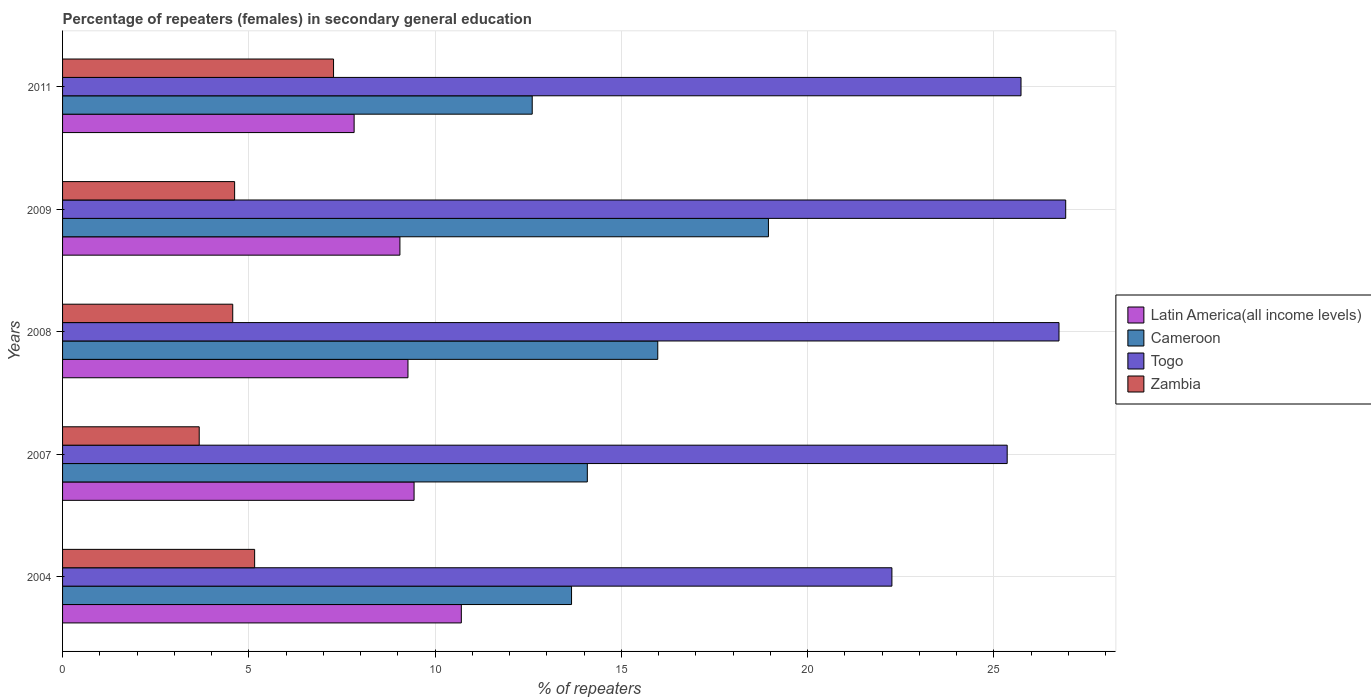How many different coloured bars are there?
Make the answer very short. 4. How many groups of bars are there?
Provide a succinct answer. 5. Are the number of bars per tick equal to the number of legend labels?
Offer a very short reply. Yes. Are the number of bars on each tick of the Y-axis equal?
Offer a terse response. Yes. How many bars are there on the 4th tick from the bottom?
Ensure brevity in your answer.  4. What is the label of the 4th group of bars from the top?
Offer a very short reply. 2007. In how many cases, is the number of bars for a given year not equal to the number of legend labels?
Ensure brevity in your answer.  0. What is the percentage of female repeaters in Latin America(all income levels) in 2008?
Your answer should be compact. 9.27. Across all years, what is the maximum percentage of female repeaters in Cameroon?
Provide a short and direct response. 18.95. Across all years, what is the minimum percentage of female repeaters in Cameroon?
Your answer should be compact. 12.61. In which year was the percentage of female repeaters in Togo minimum?
Provide a succinct answer. 2004. What is the total percentage of female repeaters in Cameroon in the graph?
Offer a terse response. 75.29. What is the difference between the percentage of female repeaters in Latin America(all income levels) in 2008 and that in 2011?
Your answer should be compact. 1.45. What is the difference between the percentage of female repeaters in Cameroon in 2008 and the percentage of female repeaters in Latin America(all income levels) in 2007?
Your answer should be compact. 6.54. What is the average percentage of female repeaters in Latin America(all income levels) per year?
Ensure brevity in your answer.  9.26. In the year 2007, what is the difference between the percentage of female repeaters in Cameroon and percentage of female repeaters in Togo?
Offer a terse response. -11.27. In how many years, is the percentage of female repeaters in Togo greater than 23 %?
Your answer should be compact. 4. What is the ratio of the percentage of female repeaters in Cameroon in 2004 to that in 2007?
Ensure brevity in your answer.  0.97. Is the difference between the percentage of female repeaters in Cameroon in 2008 and 2009 greater than the difference between the percentage of female repeaters in Togo in 2008 and 2009?
Make the answer very short. No. What is the difference between the highest and the second highest percentage of female repeaters in Togo?
Your answer should be very brief. 0.18. What is the difference between the highest and the lowest percentage of female repeaters in Zambia?
Provide a succinct answer. 3.61. In how many years, is the percentage of female repeaters in Cameroon greater than the average percentage of female repeaters in Cameroon taken over all years?
Offer a terse response. 2. Is it the case that in every year, the sum of the percentage of female repeaters in Zambia and percentage of female repeaters in Latin America(all income levels) is greater than the sum of percentage of female repeaters in Togo and percentage of female repeaters in Cameroon?
Provide a short and direct response. No. What does the 2nd bar from the top in 2007 represents?
Ensure brevity in your answer.  Togo. What does the 1st bar from the bottom in 2009 represents?
Give a very brief answer. Latin America(all income levels). Is it the case that in every year, the sum of the percentage of female repeaters in Togo and percentage of female repeaters in Cameroon is greater than the percentage of female repeaters in Latin America(all income levels)?
Your answer should be compact. Yes. Are all the bars in the graph horizontal?
Your answer should be compact. Yes. Are the values on the major ticks of X-axis written in scientific E-notation?
Your answer should be very brief. No. Where does the legend appear in the graph?
Provide a succinct answer. Center right. What is the title of the graph?
Provide a short and direct response. Percentage of repeaters (females) in secondary general education. What is the label or title of the X-axis?
Ensure brevity in your answer.  % of repeaters. What is the label or title of the Y-axis?
Your response must be concise. Years. What is the % of repeaters of Latin America(all income levels) in 2004?
Provide a short and direct response. 10.7. What is the % of repeaters in Cameroon in 2004?
Offer a terse response. 13.66. What is the % of repeaters of Togo in 2004?
Keep it short and to the point. 22.26. What is the % of repeaters of Zambia in 2004?
Make the answer very short. 5.16. What is the % of repeaters in Latin America(all income levels) in 2007?
Give a very brief answer. 9.44. What is the % of repeaters of Cameroon in 2007?
Your response must be concise. 14.09. What is the % of repeaters in Togo in 2007?
Offer a very short reply. 25.36. What is the % of repeaters in Zambia in 2007?
Your answer should be very brief. 3.67. What is the % of repeaters of Latin America(all income levels) in 2008?
Ensure brevity in your answer.  9.27. What is the % of repeaters in Cameroon in 2008?
Keep it short and to the point. 15.98. What is the % of repeaters in Togo in 2008?
Offer a terse response. 26.75. What is the % of repeaters of Zambia in 2008?
Your response must be concise. 4.57. What is the % of repeaters of Latin America(all income levels) in 2009?
Offer a terse response. 9.06. What is the % of repeaters of Cameroon in 2009?
Offer a very short reply. 18.95. What is the % of repeaters in Togo in 2009?
Offer a very short reply. 26.93. What is the % of repeaters of Zambia in 2009?
Your answer should be very brief. 4.62. What is the % of repeaters in Latin America(all income levels) in 2011?
Your answer should be compact. 7.83. What is the % of repeaters in Cameroon in 2011?
Give a very brief answer. 12.61. What is the % of repeaters in Togo in 2011?
Provide a short and direct response. 25.73. What is the % of repeaters in Zambia in 2011?
Offer a very short reply. 7.27. Across all years, what is the maximum % of repeaters of Latin America(all income levels)?
Provide a short and direct response. 10.7. Across all years, what is the maximum % of repeaters in Cameroon?
Keep it short and to the point. 18.95. Across all years, what is the maximum % of repeaters of Togo?
Provide a succinct answer. 26.93. Across all years, what is the maximum % of repeaters of Zambia?
Give a very brief answer. 7.27. Across all years, what is the minimum % of repeaters of Latin America(all income levels)?
Provide a succinct answer. 7.83. Across all years, what is the minimum % of repeaters of Cameroon?
Your response must be concise. 12.61. Across all years, what is the minimum % of repeaters in Togo?
Provide a short and direct response. 22.26. Across all years, what is the minimum % of repeaters of Zambia?
Give a very brief answer. 3.67. What is the total % of repeaters of Latin America(all income levels) in the graph?
Your answer should be compact. 46.3. What is the total % of repeaters of Cameroon in the graph?
Give a very brief answer. 75.29. What is the total % of repeaters of Togo in the graph?
Your answer should be very brief. 127.03. What is the total % of repeaters of Zambia in the graph?
Give a very brief answer. 25.29. What is the difference between the % of repeaters of Latin America(all income levels) in 2004 and that in 2007?
Your response must be concise. 1.27. What is the difference between the % of repeaters of Cameroon in 2004 and that in 2007?
Ensure brevity in your answer.  -0.42. What is the difference between the % of repeaters in Togo in 2004 and that in 2007?
Keep it short and to the point. -3.09. What is the difference between the % of repeaters of Zambia in 2004 and that in 2007?
Make the answer very short. 1.49. What is the difference between the % of repeaters of Latin America(all income levels) in 2004 and that in 2008?
Offer a very short reply. 1.43. What is the difference between the % of repeaters in Cameroon in 2004 and that in 2008?
Your answer should be very brief. -2.31. What is the difference between the % of repeaters of Togo in 2004 and that in 2008?
Offer a terse response. -4.49. What is the difference between the % of repeaters in Zambia in 2004 and that in 2008?
Your answer should be very brief. 0.59. What is the difference between the % of repeaters in Latin America(all income levels) in 2004 and that in 2009?
Make the answer very short. 1.65. What is the difference between the % of repeaters of Cameroon in 2004 and that in 2009?
Offer a terse response. -5.29. What is the difference between the % of repeaters of Togo in 2004 and that in 2009?
Ensure brevity in your answer.  -4.67. What is the difference between the % of repeaters in Zambia in 2004 and that in 2009?
Ensure brevity in your answer.  0.54. What is the difference between the % of repeaters in Latin America(all income levels) in 2004 and that in 2011?
Ensure brevity in your answer.  2.88. What is the difference between the % of repeaters in Cameroon in 2004 and that in 2011?
Your response must be concise. 1.06. What is the difference between the % of repeaters of Togo in 2004 and that in 2011?
Keep it short and to the point. -3.47. What is the difference between the % of repeaters in Zambia in 2004 and that in 2011?
Offer a very short reply. -2.12. What is the difference between the % of repeaters in Latin America(all income levels) in 2007 and that in 2008?
Ensure brevity in your answer.  0.16. What is the difference between the % of repeaters of Cameroon in 2007 and that in 2008?
Your response must be concise. -1.89. What is the difference between the % of repeaters of Togo in 2007 and that in 2008?
Ensure brevity in your answer.  -1.39. What is the difference between the % of repeaters in Latin America(all income levels) in 2007 and that in 2009?
Keep it short and to the point. 0.38. What is the difference between the % of repeaters in Cameroon in 2007 and that in 2009?
Provide a short and direct response. -4.86. What is the difference between the % of repeaters of Togo in 2007 and that in 2009?
Keep it short and to the point. -1.57. What is the difference between the % of repeaters in Zambia in 2007 and that in 2009?
Offer a very short reply. -0.95. What is the difference between the % of repeaters in Latin America(all income levels) in 2007 and that in 2011?
Offer a terse response. 1.61. What is the difference between the % of repeaters of Cameroon in 2007 and that in 2011?
Keep it short and to the point. 1.48. What is the difference between the % of repeaters in Togo in 2007 and that in 2011?
Give a very brief answer. -0.37. What is the difference between the % of repeaters of Zambia in 2007 and that in 2011?
Give a very brief answer. -3.61. What is the difference between the % of repeaters in Latin America(all income levels) in 2008 and that in 2009?
Your answer should be very brief. 0.22. What is the difference between the % of repeaters in Cameroon in 2008 and that in 2009?
Your response must be concise. -2.97. What is the difference between the % of repeaters in Togo in 2008 and that in 2009?
Ensure brevity in your answer.  -0.18. What is the difference between the % of repeaters in Zambia in 2008 and that in 2009?
Your answer should be compact. -0.05. What is the difference between the % of repeaters in Latin America(all income levels) in 2008 and that in 2011?
Offer a very short reply. 1.45. What is the difference between the % of repeaters of Cameroon in 2008 and that in 2011?
Provide a succinct answer. 3.37. What is the difference between the % of repeaters in Togo in 2008 and that in 2011?
Offer a terse response. 1.02. What is the difference between the % of repeaters of Zambia in 2008 and that in 2011?
Offer a terse response. -2.71. What is the difference between the % of repeaters in Latin America(all income levels) in 2009 and that in 2011?
Keep it short and to the point. 1.23. What is the difference between the % of repeaters in Cameroon in 2009 and that in 2011?
Ensure brevity in your answer.  6.34. What is the difference between the % of repeaters in Zambia in 2009 and that in 2011?
Provide a succinct answer. -2.66. What is the difference between the % of repeaters in Latin America(all income levels) in 2004 and the % of repeaters in Cameroon in 2007?
Give a very brief answer. -3.38. What is the difference between the % of repeaters in Latin America(all income levels) in 2004 and the % of repeaters in Togo in 2007?
Your answer should be compact. -14.65. What is the difference between the % of repeaters of Latin America(all income levels) in 2004 and the % of repeaters of Zambia in 2007?
Your response must be concise. 7.04. What is the difference between the % of repeaters of Cameroon in 2004 and the % of repeaters of Togo in 2007?
Your answer should be very brief. -11.7. What is the difference between the % of repeaters of Cameroon in 2004 and the % of repeaters of Zambia in 2007?
Your answer should be compact. 10. What is the difference between the % of repeaters in Togo in 2004 and the % of repeaters in Zambia in 2007?
Offer a very short reply. 18.6. What is the difference between the % of repeaters in Latin America(all income levels) in 2004 and the % of repeaters in Cameroon in 2008?
Your answer should be compact. -5.27. What is the difference between the % of repeaters in Latin America(all income levels) in 2004 and the % of repeaters in Togo in 2008?
Offer a very short reply. -16.04. What is the difference between the % of repeaters in Latin America(all income levels) in 2004 and the % of repeaters in Zambia in 2008?
Offer a very short reply. 6.14. What is the difference between the % of repeaters of Cameroon in 2004 and the % of repeaters of Togo in 2008?
Offer a terse response. -13.09. What is the difference between the % of repeaters of Cameroon in 2004 and the % of repeaters of Zambia in 2008?
Provide a succinct answer. 9.1. What is the difference between the % of repeaters in Togo in 2004 and the % of repeaters in Zambia in 2008?
Keep it short and to the point. 17.7. What is the difference between the % of repeaters in Latin America(all income levels) in 2004 and the % of repeaters in Cameroon in 2009?
Offer a very short reply. -8.24. What is the difference between the % of repeaters in Latin America(all income levels) in 2004 and the % of repeaters in Togo in 2009?
Provide a short and direct response. -16.22. What is the difference between the % of repeaters in Latin America(all income levels) in 2004 and the % of repeaters in Zambia in 2009?
Provide a succinct answer. 6.09. What is the difference between the % of repeaters of Cameroon in 2004 and the % of repeaters of Togo in 2009?
Offer a terse response. -13.27. What is the difference between the % of repeaters in Cameroon in 2004 and the % of repeaters in Zambia in 2009?
Provide a succinct answer. 9.04. What is the difference between the % of repeaters in Togo in 2004 and the % of repeaters in Zambia in 2009?
Provide a short and direct response. 17.65. What is the difference between the % of repeaters of Latin America(all income levels) in 2004 and the % of repeaters of Cameroon in 2011?
Your answer should be very brief. -1.9. What is the difference between the % of repeaters of Latin America(all income levels) in 2004 and the % of repeaters of Togo in 2011?
Your answer should be very brief. -15.02. What is the difference between the % of repeaters in Latin America(all income levels) in 2004 and the % of repeaters in Zambia in 2011?
Provide a succinct answer. 3.43. What is the difference between the % of repeaters of Cameroon in 2004 and the % of repeaters of Togo in 2011?
Provide a short and direct response. -12.07. What is the difference between the % of repeaters in Cameroon in 2004 and the % of repeaters in Zambia in 2011?
Keep it short and to the point. 6.39. What is the difference between the % of repeaters of Togo in 2004 and the % of repeaters of Zambia in 2011?
Offer a very short reply. 14.99. What is the difference between the % of repeaters of Latin America(all income levels) in 2007 and the % of repeaters of Cameroon in 2008?
Provide a succinct answer. -6.54. What is the difference between the % of repeaters in Latin America(all income levels) in 2007 and the % of repeaters in Togo in 2008?
Make the answer very short. -17.31. What is the difference between the % of repeaters in Latin America(all income levels) in 2007 and the % of repeaters in Zambia in 2008?
Your response must be concise. 4.87. What is the difference between the % of repeaters in Cameroon in 2007 and the % of repeaters in Togo in 2008?
Offer a very short reply. -12.66. What is the difference between the % of repeaters of Cameroon in 2007 and the % of repeaters of Zambia in 2008?
Offer a very short reply. 9.52. What is the difference between the % of repeaters of Togo in 2007 and the % of repeaters of Zambia in 2008?
Your answer should be compact. 20.79. What is the difference between the % of repeaters of Latin America(all income levels) in 2007 and the % of repeaters of Cameroon in 2009?
Your response must be concise. -9.51. What is the difference between the % of repeaters in Latin America(all income levels) in 2007 and the % of repeaters in Togo in 2009?
Your answer should be very brief. -17.49. What is the difference between the % of repeaters in Latin America(all income levels) in 2007 and the % of repeaters in Zambia in 2009?
Ensure brevity in your answer.  4.82. What is the difference between the % of repeaters of Cameroon in 2007 and the % of repeaters of Togo in 2009?
Provide a succinct answer. -12.84. What is the difference between the % of repeaters of Cameroon in 2007 and the % of repeaters of Zambia in 2009?
Offer a terse response. 9.47. What is the difference between the % of repeaters of Togo in 2007 and the % of repeaters of Zambia in 2009?
Offer a very short reply. 20.74. What is the difference between the % of repeaters in Latin America(all income levels) in 2007 and the % of repeaters in Cameroon in 2011?
Your answer should be very brief. -3.17. What is the difference between the % of repeaters of Latin America(all income levels) in 2007 and the % of repeaters of Togo in 2011?
Keep it short and to the point. -16.29. What is the difference between the % of repeaters of Latin America(all income levels) in 2007 and the % of repeaters of Zambia in 2011?
Make the answer very short. 2.16. What is the difference between the % of repeaters of Cameroon in 2007 and the % of repeaters of Togo in 2011?
Offer a very short reply. -11.64. What is the difference between the % of repeaters in Cameroon in 2007 and the % of repeaters in Zambia in 2011?
Keep it short and to the point. 6.81. What is the difference between the % of repeaters in Togo in 2007 and the % of repeaters in Zambia in 2011?
Provide a succinct answer. 18.08. What is the difference between the % of repeaters in Latin America(all income levels) in 2008 and the % of repeaters in Cameroon in 2009?
Keep it short and to the point. -9.68. What is the difference between the % of repeaters in Latin America(all income levels) in 2008 and the % of repeaters in Togo in 2009?
Provide a short and direct response. -17.66. What is the difference between the % of repeaters in Latin America(all income levels) in 2008 and the % of repeaters in Zambia in 2009?
Make the answer very short. 4.65. What is the difference between the % of repeaters of Cameroon in 2008 and the % of repeaters of Togo in 2009?
Ensure brevity in your answer.  -10.95. What is the difference between the % of repeaters in Cameroon in 2008 and the % of repeaters in Zambia in 2009?
Provide a succinct answer. 11.36. What is the difference between the % of repeaters in Togo in 2008 and the % of repeaters in Zambia in 2009?
Provide a short and direct response. 22.13. What is the difference between the % of repeaters in Latin America(all income levels) in 2008 and the % of repeaters in Cameroon in 2011?
Provide a succinct answer. -3.34. What is the difference between the % of repeaters in Latin America(all income levels) in 2008 and the % of repeaters in Togo in 2011?
Make the answer very short. -16.46. What is the difference between the % of repeaters of Latin America(all income levels) in 2008 and the % of repeaters of Zambia in 2011?
Make the answer very short. 2. What is the difference between the % of repeaters in Cameroon in 2008 and the % of repeaters in Togo in 2011?
Your response must be concise. -9.75. What is the difference between the % of repeaters in Cameroon in 2008 and the % of repeaters in Zambia in 2011?
Give a very brief answer. 8.7. What is the difference between the % of repeaters of Togo in 2008 and the % of repeaters of Zambia in 2011?
Offer a terse response. 19.47. What is the difference between the % of repeaters of Latin America(all income levels) in 2009 and the % of repeaters of Cameroon in 2011?
Offer a terse response. -3.55. What is the difference between the % of repeaters of Latin America(all income levels) in 2009 and the % of repeaters of Togo in 2011?
Your answer should be compact. -16.67. What is the difference between the % of repeaters of Latin America(all income levels) in 2009 and the % of repeaters of Zambia in 2011?
Offer a very short reply. 1.78. What is the difference between the % of repeaters of Cameroon in 2009 and the % of repeaters of Togo in 2011?
Make the answer very short. -6.78. What is the difference between the % of repeaters of Cameroon in 2009 and the % of repeaters of Zambia in 2011?
Your response must be concise. 11.67. What is the difference between the % of repeaters in Togo in 2009 and the % of repeaters in Zambia in 2011?
Your answer should be very brief. 19.66. What is the average % of repeaters of Latin America(all income levels) per year?
Your answer should be very brief. 9.26. What is the average % of repeaters of Cameroon per year?
Provide a succinct answer. 15.06. What is the average % of repeaters of Togo per year?
Keep it short and to the point. 25.41. What is the average % of repeaters of Zambia per year?
Keep it short and to the point. 5.06. In the year 2004, what is the difference between the % of repeaters of Latin America(all income levels) and % of repeaters of Cameroon?
Give a very brief answer. -2.96. In the year 2004, what is the difference between the % of repeaters of Latin America(all income levels) and % of repeaters of Togo?
Make the answer very short. -11.56. In the year 2004, what is the difference between the % of repeaters in Latin America(all income levels) and % of repeaters in Zambia?
Offer a very short reply. 5.55. In the year 2004, what is the difference between the % of repeaters of Cameroon and % of repeaters of Togo?
Provide a short and direct response. -8.6. In the year 2004, what is the difference between the % of repeaters in Cameroon and % of repeaters in Zambia?
Ensure brevity in your answer.  8.51. In the year 2004, what is the difference between the % of repeaters of Togo and % of repeaters of Zambia?
Provide a short and direct response. 17.11. In the year 2007, what is the difference between the % of repeaters in Latin America(all income levels) and % of repeaters in Cameroon?
Provide a succinct answer. -4.65. In the year 2007, what is the difference between the % of repeaters of Latin America(all income levels) and % of repeaters of Togo?
Your response must be concise. -15.92. In the year 2007, what is the difference between the % of repeaters in Latin America(all income levels) and % of repeaters in Zambia?
Provide a short and direct response. 5.77. In the year 2007, what is the difference between the % of repeaters of Cameroon and % of repeaters of Togo?
Make the answer very short. -11.27. In the year 2007, what is the difference between the % of repeaters in Cameroon and % of repeaters in Zambia?
Provide a short and direct response. 10.42. In the year 2007, what is the difference between the % of repeaters in Togo and % of repeaters in Zambia?
Offer a very short reply. 21.69. In the year 2008, what is the difference between the % of repeaters in Latin America(all income levels) and % of repeaters in Cameroon?
Offer a terse response. -6.71. In the year 2008, what is the difference between the % of repeaters in Latin America(all income levels) and % of repeaters in Togo?
Your response must be concise. -17.48. In the year 2008, what is the difference between the % of repeaters of Latin America(all income levels) and % of repeaters of Zambia?
Your response must be concise. 4.7. In the year 2008, what is the difference between the % of repeaters in Cameroon and % of repeaters in Togo?
Provide a succinct answer. -10.77. In the year 2008, what is the difference between the % of repeaters in Cameroon and % of repeaters in Zambia?
Provide a succinct answer. 11.41. In the year 2008, what is the difference between the % of repeaters of Togo and % of repeaters of Zambia?
Provide a short and direct response. 22.18. In the year 2009, what is the difference between the % of repeaters of Latin America(all income levels) and % of repeaters of Cameroon?
Provide a succinct answer. -9.89. In the year 2009, what is the difference between the % of repeaters in Latin America(all income levels) and % of repeaters in Togo?
Your answer should be compact. -17.87. In the year 2009, what is the difference between the % of repeaters of Latin America(all income levels) and % of repeaters of Zambia?
Keep it short and to the point. 4.44. In the year 2009, what is the difference between the % of repeaters in Cameroon and % of repeaters in Togo?
Your answer should be compact. -7.98. In the year 2009, what is the difference between the % of repeaters in Cameroon and % of repeaters in Zambia?
Offer a terse response. 14.33. In the year 2009, what is the difference between the % of repeaters of Togo and % of repeaters of Zambia?
Ensure brevity in your answer.  22.31. In the year 2011, what is the difference between the % of repeaters in Latin America(all income levels) and % of repeaters in Cameroon?
Make the answer very short. -4.78. In the year 2011, what is the difference between the % of repeaters in Latin America(all income levels) and % of repeaters in Togo?
Your response must be concise. -17.9. In the year 2011, what is the difference between the % of repeaters of Latin America(all income levels) and % of repeaters of Zambia?
Keep it short and to the point. 0.55. In the year 2011, what is the difference between the % of repeaters in Cameroon and % of repeaters in Togo?
Offer a very short reply. -13.12. In the year 2011, what is the difference between the % of repeaters of Cameroon and % of repeaters of Zambia?
Provide a succinct answer. 5.33. In the year 2011, what is the difference between the % of repeaters of Togo and % of repeaters of Zambia?
Offer a terse response. 18.46. What is the ratio of the % of repeaters of Latin America(all income levels) in 2004 to that in 2007?
Provide a succinct answer. 1.13. What is the ratio of the % of repeaters in Cameroon in 2004 to that in 2007?
Keep it short and to the point. 0.97. What is the ratio of the % of repeaters of Togo in 2004 to that in 2007?
Provide a succinct answer. 0.88. What is the ratio of the % of repeaters of Zambia in 2004 to that in 2007?
Ensure brevity in your answer.  1.41. What is the ratio of the % of repeaters of Latin America(all income levels) in 2004 to that in 2008?
Provide a short and direct response. 1.15. What is the ratio of the % of repeaters of Cameroon in 2004 to that in 2008?
Ensure brevity in your answer.  0.86. What is the ratio of the % of repeaters of Togo in 2004 to that in 2008?
Make the answer very short. 0.83. What is the ratio of the % of repeaters of Zambia in 2004 to that in 2008?
Offer a very short reply. 1.13. What is the ratio of the % of repeaters in Latin America(all income levels) in 2004 to that in 2009?
Ensure brevity in your answer.  1.18. What is the ratio of the % of repeaters of Cameroon in 2004 to that in 2009?
Keep it short and to the point. 0.72. What is the ratio of the % of repeaters in Togo in 2004 to that in 2009?
Make the answer very short. 0.83. What is the ratio of the % of repeaters in Zambia in 2004 to that in 2009?
Your response must be concise. 1.12. What is the ratio of the % of repeaters in Latin America(all income levels) in 2004 to that in 2011?
Ensure brevity in your answer.  1.37. What is the ratio of the % of repeaters of Cameroon in 2004 to that in 2011?
Offer a terse response. 1.08. What is the ratio of the % of repeaters in Togo in 2004 to that in 2011?
Make the answer very short. 0.87. What is the ratio of the % of repeaters of Zambia in 2004 to that in 2011?
Ensure brevity in your answer.  0.71. What is the ratio of the % of repeaters in Latin America(all income levels) in 2007 to that in 2008?
Your response must be concise. 1.02. What is the ratio of the % of repeaters in Cameroon in 2007 to that in 2008?
Give a very brief answer. 0.88. What is the ratio of the % of repeaters of Togo in 2007 to that in 2008?
Make the answer very short. 0.95. What is the ratio of the % of repeaters of Zambia in 2007 to that in 2008?
Your answer should be compact. 0.8. What is the ratio of the % of repeaters in Latin America(all income levels) in 2007 to that in 2009?
Make the answer very short. 1.04. What is the ratio of the % of repeaters of Cameroon in 2007 to that in 2009?
Offer a very short reply. 0.74. What is the ratio of the % of repeaters in Togo in 2007 to that in 2009?
Your response must be concise. 0.94. What is the ratio of the % of repeaters of Zambia in 2007 to that in 2009?
Ensure brevity in your answer.  0.79. What is the ratio of the % of repeaters in Latin America(all income levels) in 2007 to that in 2011?
Offer a very short reply. 1.21. What is the ratio of the % of repeaters in Cameroon in 2007 to that in 2011?
Your answer should be very brief. 1.12. What is the ratio of the % of repeaters in Togo in 2007 to that in 2011?
Give a very brief answer. 0.99. What is the ratio of the % of repeaters in Zambia in 2007 to that in 2011?
Your answer should be compact. 0.5. What is the ratio of the % of repeaters of Latin America(all income levels) in 2008 to that in 2009?
Keep it short and to the point. 1.02. What is the ratio of the % of repeaters in Cameroon in 2008 to that in 2009?
Keep it short and to the point. 0.84. What is the ratio of the % of repeaters of Zambia in 2008 to that in 2009?
Your answer should be compact. 0.99. What is the ratio of the % of repeaters of Latin America(all income levels) in 2008 to that in 2011?
Your answer should be compact. 1.18. What is the ratio of the % of repeaters in Cameroon in 2008 to that in 2011?
Ensure brevity in your answer.  1.27. What is the ratio of the % of repeaters of Togo in 2008 to that in 2011?
Give a very brief answer. 1.04. What is the ratio of the % of repeaters of Zambia in 2008 to that in 2011?
Give a very brief answer. 0.63. What is the ratio of the % of repeaters of Latin America(all income levels) in 2009 to that in 2011?
Your answer should be very brief. 1.16. What is the ratio of the % of repeaters in Cameroon in 2009 to that in 2011?
Offer a terse response. 1.5. What is the ratio of the % of repeaters of Togo in 2009 to that in 2011?
Your response must be concise. 1.05. What is the ratio of the % of repeaters in Zambia in 2009 to that in 2011?
Offer a terse response. 0.63. What is the difference between the highest and the second highest % of repeaters in Latin America(all income levels)?
Offer a terse response. 1.27. What is the difference between the highest and the second highest % of repeaters of Cameroon?
Your answer should be compact. 2.97. What is the difference between the highest and the second highest % of repeaters in Togo?
Give a very brief answer. 0.18. What is the difference between the highest and the second highest % of repeaters of Zambia?
Offer a terse response. 2.12. What is the difference between the highest and the lowest % of repeaters in Latin America(all income levels)?
Provide a succinct answer. 2.88. What is the difference between the highest and the lowest % of repeaters in Cameroon?
Give a very brief answer. 6.34. What is the difference between the highest and the lowest % of repeaters of Togo?
Make the answer very short. 4.67. What is the difference between the highest and the lowest % of repeaters of Zambia?
Provide a succinct answer. 3.61. 